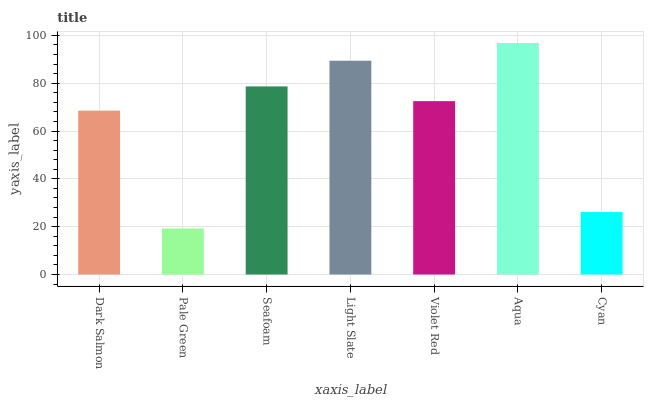Is Pale Green the minimum?
Answer yes or no. Yes. Is Aqua the maximum?
Answer yes or no. Yes. Is Seafoam the minimum?
Answer yes or no. No. Is Seafoam the maximum?
Answer yes or no. No. Is Seafoam greater than Pale Green?
Answer yes or no. Yes. Is Pale Green less than Seafoam?
Answer yes or no. Yes. Is Pale Green greater than Seafoam?
Answer yes or no. No. Is Seafoam less than Pale Green?
Answer yes or no. No. Is Violet Red the high median?
Answer yes or no. Yes. Is Violet Red the low median?
Answer yes or no. Yes. Is Seafoam the high median?
Answer yes or no. No. Is Dark Salmon the low median?
Answer yes or no. No. 